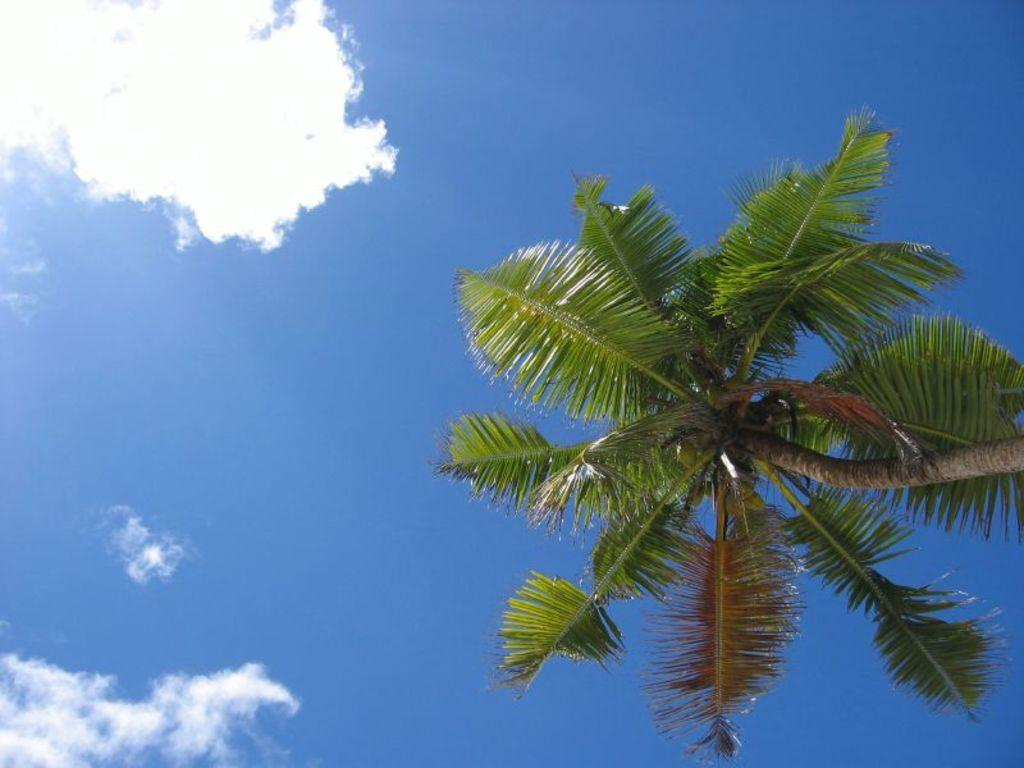What type of tree is in the image? There is a coconut tree in the image. What can be found on the coconut tree? The coconut tree has coconuts. What is the color of the sky in the background of the image? The sky is blue in the background of the image. What else can be seen in the sky? White clouds are visible in the sky. How many pickles are hanging from the coconut tree in the image? There are no pickles present in the image; it features a coconut tree with coconuts. 